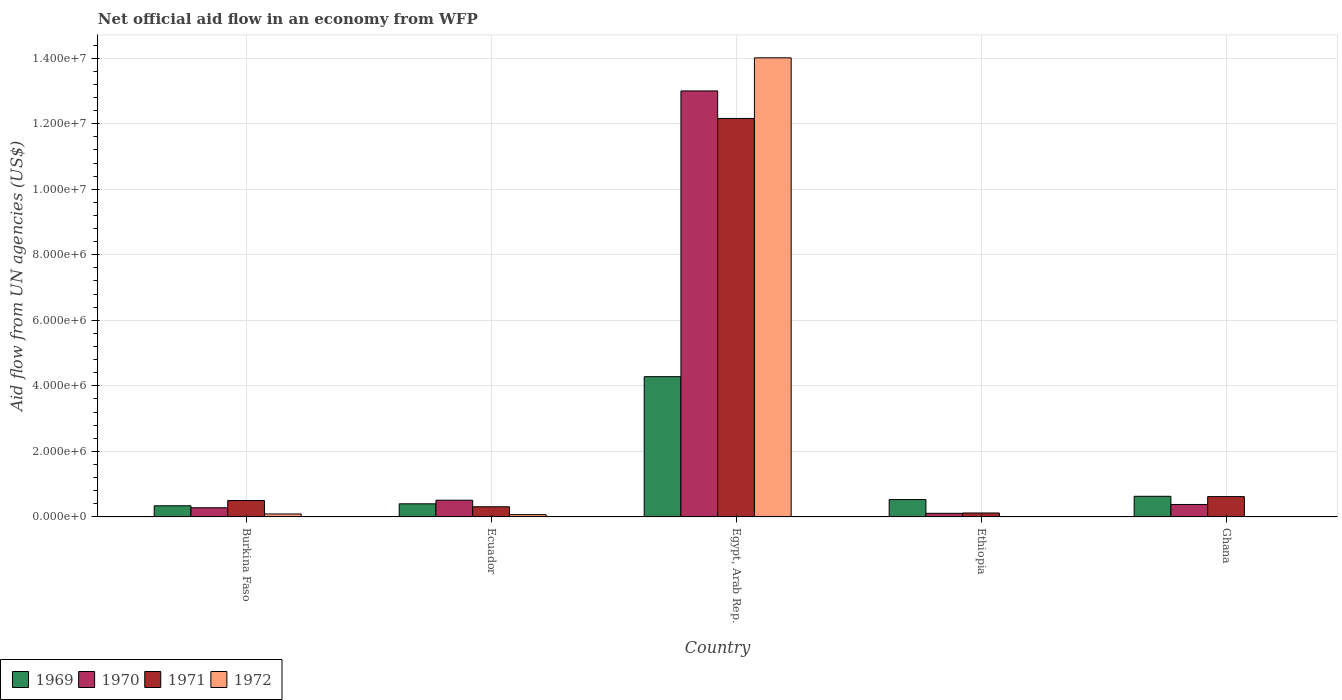How many different coloured bars are there?
Your response must be concise. 4. Are the number of bars per tick equal to the number of legend labels?
Your answer should be very brief. No. How many bars are there on the 2nd tick from the right?
Offer a very short reply. 3. What is the label of the 2nd group of bars from the left?
Give a very brief answer. Ecuador. What is the net official aid flow in 1969 in Burkina Faso?
Ensure brevity in your answer.  3.40e+05. Across all countries, what is the maximum net official aid flow in 1970?
Ensure brevity in your answer.  1.30e+07. In which country was the net official aid flow in 1972 maximum?
Keep it short and to the point. Egypt, Arab Rep. What is the total net official aid flow in 1970 in the graph?
Your answer should be very brief. 1.43e+07. What is the difference between the net official aid flow in 1970 in Ecuador and the net official aid flow in 1971 in Egypt, Arab Rep.?
Make the answer very short. -1.16e+07. What is the average net official aid flow in 1969 per country?
Provide a succinct answer. 1.24e+06. What is the difference between the net official aid flow of/in 1970 and net official aid flow of/in 1971 in Ecuador?
Keep it short and to the point. 2.00e+05. In how many countries, is the net official aid flow in 1969 greater than 3600000 US$?
Make the answer very short. 1. What is the ratio of the net official aid flow in 1972 in Ecuador to that in Egypt, Arab Rep.?
Provide a succinct answer. 0. Is the net official aid flow in 1971 in Burkina Faso less than that in Egypt, Arab Rep.?
Offer a very short reply. Yes. What is the difference between the highest and the second highest net official aid flow in 1969?
Your answer should be very brief. 3.75e+06. What is the difference between the highest and the lowest net official aid flow in 1971?
Your response must be concise. 1.20e+07. In how many countries, is the net official aid flow in 1970 greater than the average net official aid flow in 1970 taken over all countries?
Your answer should be very brief. 1. Is it the case that in every country, the sum of the net official aid flow in 1970 and net official aid flow in 1969 is greater than the net official aid flow in 1972?
Keep it short and to the point. Yes. How many bars are there?
Keep it short and to the point. 18. Are all the bars in the graph horizontal?
Offer a terse response. No. What is the difference between two consecutive major ticks on the Y-axis?
Your response must be concise. 2.00e+06. Are the values on the major ticks of Y-axis written in scientific E-notation?
Your answer should be very brief. Yes. Does the graph contain any zero values?
Your answer should be compact. Yes. What is the title of the graph?
Your answer should be very brief. Net official aid flow in an economy from WFP. What is the label or title of the Y-axis?
Your answer should be very brief. Aid flow from UN agencies (US$). What is the Aid flow from UN agencies (US$) of 1970 in Burkina Faso?
Keep it short and to the point. 2.80e+05. What is the Aid flow from UN agencies (US$) in 1971 in Burkina Faso?
Your response must be concise. 5.00e+05. What is the Aid flow from UN agencies (US$) of 1969 in Ecuador?
Your answer should be very brief. 4.00e+05. What is the Aid flow from UN agencies (US$) of 1970 in Ecuador?
Make the answer very short. 5.10e+05. What is the Aid flow from UN agencies (US$) in 1971 in Ecuador?
Make the answer very short. 3.10e+05. What is the Aid flow from UN agencies (US$) in 1969 in Egypt, Arab Rep.?
Give a very brief answer. 4.28e+06. What is the Aid flow from UN agencies (US$) in 1970 in Egypt, Arab Rep.?
Provide a succinct answer. 1.30e+07. What is the Aid flow from UN agencies (US$) in 1971 in Egypt, Arab Rep.?
Your answer should be compact. 1.22e+07. What is the Aid flow from UN agencies (US$) in 1972 in Egypt, Arab Rep.?
Make the answer very short. 1.40e+07. What is the Aid flow from UN agencies (US$) in 1969 in Ethiopia?
Give a very brief answer. 5.30e+05. What is the Aid flow from UN agencies (US$) of 1970 in Ethiopia?
Offer a terse response. 1.10e+05. What is the Aid flow from UN agencies (US$) in 1971 in Ethiopia?
Your answer should be very brief. 1.20e+05. What is the Aid flow from UN agencies (US$) in 1969 in Ghana?
Keep it short and to the point. 6.30e+05. What is the Aid flow from UN agencies (US$) in 1970 in Ghana?
Your answer should be very brief. 3.80e+05. What is the Aid flow from UN agencies (US$) of 1971 in Ghana?
Offer a terse response. 6.20e+05. Across all countries, what is the maximum Aid flow from UN agencies (US$) of 1969?
Your answer should be compact. 4.28e+06. Across all countries, what is the maximum Aid flow from UN agencies (US$) in 1970?
Give a very brief answer. 1.30e+07. Across all countries, what is the maximum Aid flow from UN agencies (US$) of 1971?
Your answer should be compact. 1.22e+07. Across all countries, what is the maximum Aid flow from UN agencies (US$) of 1972?
Ensure brevity in your answer.  1.40e+07. What is the total Aid flow from UN agencies (US$) of 1969 in the graph?
Provide a short and direct response. 6.18e+06. What is the total Aid flow from UN agencies (US$) in 1970 in the graph?
Offer a terse response. 1.43e+07. What is the total Aid flow from UN agencies (US$) in 1971 in the graph?
Ensure brevity in your answer.  1.37e+07. What is the total Aid flow from UN agencies (US$) of 1972 in the graph?
Your answer should be very brief. 1.42e+07. What is the difference between the Aid flow from UN agencies (US$) of 1969 in Burkina Faso and that in Ecuador?
Keep it short and to the point. -6.00e+04. What is the difference between the Aid flow from UN agencies (US$) of 1969 in Burkina Faso and that in Egypt, Arab Rep.?
Offer a very short reply. -3.94e+06. What is the difference between the Aid flow from UN agencies (US$) in 1970 in Burkina Faso and that in Egypt, Arab Rep.?
Your answer should be very brief. -1.27e+07. What is the difference between the Aid flow from UN agencies (US$) of 1971 in Burkina Faso and that in Egypt, Arab Rep.?
Ensure brevity in your answer.  -1.17e+07. What is the difference between the Aid flow from UN agencies (US$) in 1972 in Burkina Faso and that in Egypt, Arab Rep.?
Offer a very short reply. -1.39e+07. What is the difference between the Aid flow from UN agencies (US$) of 1969 in Burkina Faso and that in Ethiopia?
Your response must be concise. -1.90e+05. What is the difference between the Aid flow from UN agencies (US$) of 1971 in Burkina Faso and that in Ethiopia?
Ensure brevity in your answer.  3.80e+05. What is the difference between the Aid flow from UN agencies (US$) in 1970 in Burkina Faso and that in Ghana?
Make the answer very short. -1.00e+05. What is the difference between the Aid flow from UN agencies (US$) of 1971 in Burkina Faso and that in Ghana?
Your answer should be compact. -1.20e+05. What is the difference between the Aid flow from UN agencies (US$) of 1969 in Ecuador and that in Egypt, Arab Rep.?
Make the answer very short. -3.88e+06. What is the difference between the Aid flow from UN agencies (US$) of 1970 in Ecuador and that in Egypt, Arab Rep.?
Your answer should be compact. -1.25e+07. What is the difference between the Aid flow from UN agencies (US$) in 1971 in Ecuador and that in Egypt, Arab Rep.?
Provide a succinct answer. -1.18e+07. What is the difference between the Aid flow from UN agencies (US$) in 1972 in Ecuador and that in Egypt, Arab Rep.?
Your response must be concise. -1.39e+07. What is the difference between the Aid flow from UN agencies (US$) in 1971 in Ecuador and that in Ethiopia?
Offer a very short reply. 1.90e+05. What is the difference between the Aid flow from UN agencies (US$) of 1971 in Ecuador and that in Ghana?
Your response must be concise. -3.10e+05. What is the difference between the Aid flow from UN agencies (US$) in 1969 in Egypt, Arab Rep. and that in Ethiopia?
Provide a succinct answer. 3.75e+06. What is the difference between the Aid flow from UN agencies (US$) in 1970 in Egypt, Arab Rep. and that in Ethiopia?
Your response must be concise. 1.29e+07. What is the difference between the Aid flow from UN agencies (US$) of 1971 in Egypt, Arab Rep. and that in Ethiopia?
Make the answer very short. 1.20e+07. What is the difference between the Aid flow from UN agencies (US$) in 1969 in Egypt, Arab Rep. and that in Ghana?
Provide a short and direct response. 3.65e+06. What is the difference between the Aid flow from UN agencies (US$) of 1970 in Egypt, Arab Rep. and that in Ghana?
Keep it short and to the point. 1.26e+07. What is the difference between the Aid flow from UN agencies (US$) of 1971 in Egypt, Arab Rep. and that in Ghana?
Provide a short and direct response. 1.15e+07. What is the difference between the Aid flow from UN agencies (US$) in 1969 in Ethiopia and that in Ghana?
Provide a short and direct response. -1.00e+05. What is the difference between the Aid flow from UN agencies (US$) of 1971 in Ethiopia and that in Ghana?
Provide a short and direct response. -5.00e+05. What is the difference between the Aid flow from UN agencies (US$) of 1969 in Burkina Faso and the Aid flow from UN agencies (US$) of 1972 in Ecuador?
Offer a very short reply. 2.70e+05. What is the difference between the Aid flow from UN agencies (US$) in 1970 in Burkina Faso and the Aid flow from UN agencies (US$) in 1972 in Ecuador?
Ensure brevity in your answer.  2.10e+05. What is the difference between the Aid flow from UN agencies (US$) in 1969 in Burkina Faso and the Aid flow from UN agencies (US$) in 1970 in Egypt, Arab Rep.?
Ensure brevity in your answer.  -1.27e+07. What is the difference between the Aid flow from UN agencies (US$) of 1969 in Burkina Faso and the Aid flow from UN agencies (US$) of 1971 in Egypt, Arab Rep.?
Make the answer very short. -1.18e+07. What is the difference between the Aid flow from UN agencies (US$) of 1969 in Burkina Faso and the Aid flow from UN agencies (US$) of 1972 in Egypt, Arab Rep.?
Ensure brevity in your answer.  -1.37e+07. What is the difference between the Aid flow from UN agencies (US$) in 1970 in Burkina Faso and the Aid flow from UN agencies (US$) in 1971 in Egypt, Arab Rep.?
Offer a terse response. -1.19e+07. What is the difference between the Aid flow from UN agencies (US$) in 1970 in Burkina Faso and the Aid flow from UN agencies (US$) in 1972 in Egypt, Arab Rep.?
Keep it short and to the point. -1.37e+07. What is the difference between the Aid flow from UN agencies (US$) in 1971 in Burkina Faso and the Aid flow from UN agencies (US$) in 1972 in Egypt, Arab Rep.?
Keep it short and to the point. -1.35e+07. What is the difference between the Aid flow from UN agencies (US$) of 1969 in Burkina Faso and the Aid flow from UN agencies (US$) of 1971 in Ethiopia?
Provide a short and direct response. 2.20e+05. What is the difference between the Aid flow from UN agencies (US$) of 1969 in Burkina Faso and the Aid flow from UN agencies (US$) of 1970 in Ghana?
Provide a short and direct response. -4.00e+04. What is the difference between the Aid flow from UN agencies (US$) of 1969 in Burkina Faso and the Aid flow from UN agencies (US$) of 1971 in Ghana?
Ensure brevity in your answer.  -2.80e+05. What is the difference between the Aid flow from UN agencies (US$) in 1969 in Ecuador and the Aid flow from UN agencies (US$) in 1970 in Egypt, Arab Rep.?
Your answer should be compact. -1.26e+07. What is the difference between the Aid flow from UN agencies (US$) of 1969 in Ecuador and the Aid flow from UN agencies (US$) of 1971 in Egypt, Arab Rep.?
Give a very brief answer. -1.18e+07. What is the difference between the Aid flow from UN agencies (US$) in 1969 in Ecuador and the Aid flow from UN agencies (US$) in 1972 in Egypt, Arab Rep.?
Offer a terse response. -1.36e+07. What is the difference between the Aid flow from UN agencies (US$) of 1970 in Ecuador and the Aid flow from UN agencies (US$) of 1971 in Egypt, Arab Rep.?
Your answer should be compact. -1.16e+07. What is the difference between the Aid flow from UN agencies (US$) of 1970 in Ecuador and the Aid flow from UN agencies (US$) of 1972 in Egypt, Arab Rep.?
Provide a short and direct response. -1.35e+07. What is the difference between the Aid flow from UN agencies (US$) in 1971 in Ecuador and the Aid flow from UN agencies (US$) in 1972 in Egypt, Arab Rep.?
Your answer should be very brief. -1.37e+07. What is the difference between the Aid flow from UN agencies (US$) of 1969 in Ecuador and the Aid flow from UN agencies (US$) of 1970 in Ethiopia?
Your answer should be very brief. 2.90e+05. What is the difference between the Aid flow from UN agencies (US$) in 1970 in Ecuador and the Aid flow from UN agencies (US$) in 1971 in Ghana?
Ensure brevity in your answer.  -1.10e+05. What is the difference between the Aid flow from UN agencies (US$) of 1969 in Egypt, Arab Rep. and the Aid flow from UN agencies (US$) of 1970 in Ethiopia?
Keep it short and to the point. 4.17e+06. What is the difference between the Aid flow from UN agencies (US$) of 1969 in Egypt, Arab Rep. and the Aid flow from UN agencies (US$) of 1971 in Ethiopia?
Ensure brevity in your answer.  4.16e+06. What is the difference between the Aid flow from UN agencies (US$) in 1970 in Egypt, Arab Rep. and the Aid flow from UN agencies (US$) in 1971 in Ethiopia?
Keep it short and to the point. 1.29e+07. What is the difference between the Aid flow from UN agencies (US$) of 1969 in Egypt, Arab Rep. and the Aid flow from UN agencies (US$) of 1970 in Ghana?
Offer a very short reply. 3.90e+06. What is the difference between the Aid flow from UN agencies (US$) in 1969 in Egypt, Arab Rep. and the Aid flow from UN agencies (US$) in 1971 in Ghana?
Provide a succinct answer. 3.66e+06. What is the difference between the Aid flow from UN agencies (US$) of 1970 in Egypt, Arab Rep. and the Aid flow from UN agencies (US$) of 1971 in Ghana?
Keep it short and to the point. 1.24e+07. What is the difference between the Aid flow from UN agencies (US$) of 1969 in Ethiopia and the Aid flow from UN agencies (US$) of 1970 in Ghana?
Provide a short and direct response. 1.50e+05. What is the difference between the Aid flow from UN agencies (US$) in 1970 in Ethiopia and the Aid flow from UN agencies (US$) in 1971 in Ghana?
Your response must be concise. -5.10e+05. What is the average Aid flow from UN agencies (US$) in 1969 per country?
Keep it short and to the point. 1.24e+06. What is the average Aid flow from UN agencies (US$) in 1970 per country?
Provide a short and direct response. 2.86e+06. What is the average Aid flow from UN agencies (US$) of 1971 per country?
Your answer should be very brief. 2.74e+06. What is the average Aid flow from UN agencies (US$) in 1972 per country?
Your answer should be very brief. 2.83e+06. What is the difference between the Aid flow from UN agencies (US$) in 1969 and Aid flow from UN agencies (US$) in 1970 in Burkina Faso?
Provide a short and direct response. 6.00e+04. What is the difference between the Aid flow from UN agencies (US$) in 1969 and Aid flow from UN agencies (US$) in 1971 in Burkina Faso?
Provide a short and direct response. -1.60e+05. What is the difference between the Aid flow from UN agencies (US$) in 1969 and Aid flow from UN agencies (US$) in 1972 in Burkina Faso?
Provide a succinct answer. 2.50e+05. What is the difference between the Aid flow from UN agencies (US$) in 1970 and Aid flow from UN agencies (US$) in 1971 in Burkina Faso?
Ensure brevity in your answer.  -2.20e+05. What is the difference between the Aid flow from UN agencies (US$) in 1969 and Aid flow from UN agencies (US$) in 1971 in Ecuador?
Offer a terse response. 9.00e+04. What is the difference between the Aid flow from UN agencies (US$) in 1969 and Aid flow from UN agencies (US$) in 1972 in Ecuador?
Your answer should be very brief. 3.30e+05. What is the difference between the Aid flow from UN agencies (US$) in 1969 and Aid flow from UN agencies (US$) in 1970 in Egypt, Arab Rep.?
Give a very brief answer. -8.72e+06. What is the difference between the Aid flow from UN agencies (US$) in 1969 and Aid flow from UN agencies (US$) in 1971 in Egypt, Arab Rep.?
Your answer should be very brief. -7.88e+06. What is the difference between the Aid flow from UN agencies (US$) in 1969 and Aid flow from UN agencies (US$) in 1972 in Egypt, Arab Rep.?
Offer a very short reply. -9.73e+06. What is the difference between the Aid flow from UN agencies (US$) in 1970 and Aid flow from UN agencies (US$) in 1971 in Egypt, Arab Rep.?
Provide a short and direct response. 8.40e+05. What is the difference between the Aid flow from UN agencies (US$) of 1970 and Aid flow from UN agencies (US$) of 1972 in Egypt, Arab Rep.?
Your answer should be very brief. -1.01e+06. What is the difference between the Aid flow from UN agencies (US$) in 1971 and Aid flow from UN agencies (US$) in 1972 in Egypt, Arab Rep.?
Make the answer very short. -1.85e+06. What is the difference between the Aid flow from UN agencies (US$) in 1969 and Aid flow from UN agencies (US$) in 1970 in Ethiopia?
Offer a terse response. 4.20e+05. What is the ratio of the Aid flow from UN agencies (US$) of 1970 in Burkina Faso to that in Ecuador?
Your response must be concise. 0.55. What is the ratio of the Aid flow from UN agencies (US$) in 1971 in Burkina Faso to that in Ecuador?
Ensure brevity in your answer.  1.61. What is the ratio of the Aid flow from UN agencies (US$) in 1969 in Burkina Faso to that in Egypt, Arab Rep.?
Ensure brevity in your answer.  0.08. What is the ratio of the Aid flow from UN agencies (US$) in 1970 in Burkina Faso to that in Egypt, Arab Rep.?
Offer a terse response. 0.02. What is the ratio of the Aid flow from UN agencies (US$) in 1971 in Burkina Faso to that in Egypt, Arab Rep.?
Give a very brief answer. 0.04. What is the ratio of the Aid flow from UN agencies (US$) in 1972 in Burkina Faso to that in Egypt, Arab Rep.?
Your response must be concise. 0.01. What is the ratio of the Aid flow from UN agencies (US$) of 1969 in Burkina Faso to that in Ethiopia?
Provide a succinct answer. 0.64. What is the ratio of the Aid flow from UN agencies (US$) of 1970 in Burkina Faso to that in Ethiopia?
Provide a succinct answer. 2.55. What is the ratio of the Aid flow from UN agencies (US$) of 1971 in Burkina Faso to that in Ethiopia?
Provide a succinct answer. 4.17. What is the ratio of the Aid flow from UN agencies (US$) of 1969 in Burkina Faso to that in Ghana?
Offer a terse response. 0.54. What is the ratio of the Aid flow from UN agencies (US$) of 1970 in Burkina Faso to that in Ghana?
Ensure brevity in your answer.  0.74. What is the ratio of the Aid flow from UN agencies (US$) of 1971 in Burkina Faso to that in Ghana?
Offer a terse response. 0.81. What is the ratio of the Aid flow from UN agencies (US$) in 1969 in Ecuador to that in Egypt, Arab Rep.?
Your answer should be compact. 0.09. What is the ratio of the Aid flow from UN agencies (US$) of 1970 in Ecuador to that in Egypt, Arab Rep.?
Ensure brevity in your answer.  0.04. What is the ratio of the Aid flow from UN agencies (US$) of 1971 in Ecuador to that in Egypt, Arab Rep.?
Provide a short and direct response. 0.03. What is the ratio of the Aid flow from UN agencies (US$) of 1972 in Ecuador to that in Egypt, Arab Rep.?
Your response must be concise. 0.01. What is the ratio of the Aid flow from UN agencies (US$) of 1969 in Ecuador to that in Ethiopia?
Offer a very short reply. 0.75. What is the ratio of the Aid flow from UN agencies (US$) of 1970 in Ecuador to that in Ethiopia?
Give a very brief answer. 4.64. What is the ratio of the Aid flow from UN agencies (US$) in 1971 in Ecuador to that in Ethiopia?
Make the answer very short. 2.58. What is the ratio of the Aid flow from UN agencies (US$) in 1969 in Ecuador to that in Ghana?
Offer a terse response. 0.63. What is the ratio of the Aid flow from UN agencies (US$) of 1970 in Ecuador to that in Ghana?
Give a very brief answer. 1.34. What is the ratio of the Aid flow from UN agencies (US$) of 1971 in Ecuador to that in Ghana?
Your response must be concise. 0.5. What is the ratio of the Aid flow from UN agencies (US$) of 1969 in Egypt, Arab Rep. to that in Ethiopia?
Make the answer very short. 8.08. What is the ratio of the Aid flow from UN agencies (US$) in 1970 in Egypt, Arab Rep. to that in Ethiopia?
Offer a terse response. 118.18. What is the ratio of the Aid flow from UN agencies (US$) of 1971 in Egypt, Arab Rep. to that in Ethiopia?
Ensure brevity in your answer.  101.33. What is the ratio of the Aid flow from UN agencies (US$) in 1969 in Egypt, Arab Rep. to that in Ghana?
Provide a short and direct response. 6.79. What is the ratio of the Aid flow from UN agencies (US$) of 1970 in Egypt, Arab Rep. to that in Ghana?
Keep it short and to the point. 34.21. What is the ratio of the Aid flow from UN agencies (US$) of 1971 in Egypt, Arab Rep. to that in Ghana?
Provide a short and direct response. 19.61. What is the ratio of the Aid flow from UN agencies (US$) in 1969 in Ethiopia to that in Ghana?
Ensure brevity in your answer.  0.84. What is the ratio of the Aid flow from UN agencies (US$) in 1970 in Ethiopia to that in Ghana?
Give a very brief answer. 0.29. What is the ratio of the Aid flow from UN agencies (US$) of 1971 in Ethiopia to that in Ghana?
Ensure brevity in your answer.  0.19. What is the difference between the highest and the second highest Aid flow from UN agencies (US$) of 1969?
Ensure brevity in your answer.  3.65e+06. What is the difference between the highest and the second highest Aid flow from UN agencies (US$) in 1970?
Offer a very short reply. 1.25e+07. What is the difference between the highest and the second highest Aid flow from UN agencies (US$) of 1971?
Keep it short and to the point. 1.15e+07. What is the difference between the highest and the second highest Aid flow from UN agencies (US$) of 1972?
Keep it short and to the point. 1.39e+07. What is the difference between the highest and the lowest Aid flow from UN agencies (US$) in 1969?
Your response must be concise. 3.94e+06. What is the difference between the highest and the lowest Aid flow from UN agencies (US$) of 1970?
Ensure brevity in your answer.  1.29e+07. What is the difference between the highest and the lowest Aid flow from UN agencies (US$) of 1971?
Ensure brevity in your answer.  1.20e+07. What is the difference between the highest and the lowest Aid flow from UN agencies (US$) in 1972?
Make the answer very short. 1.40e+07. 